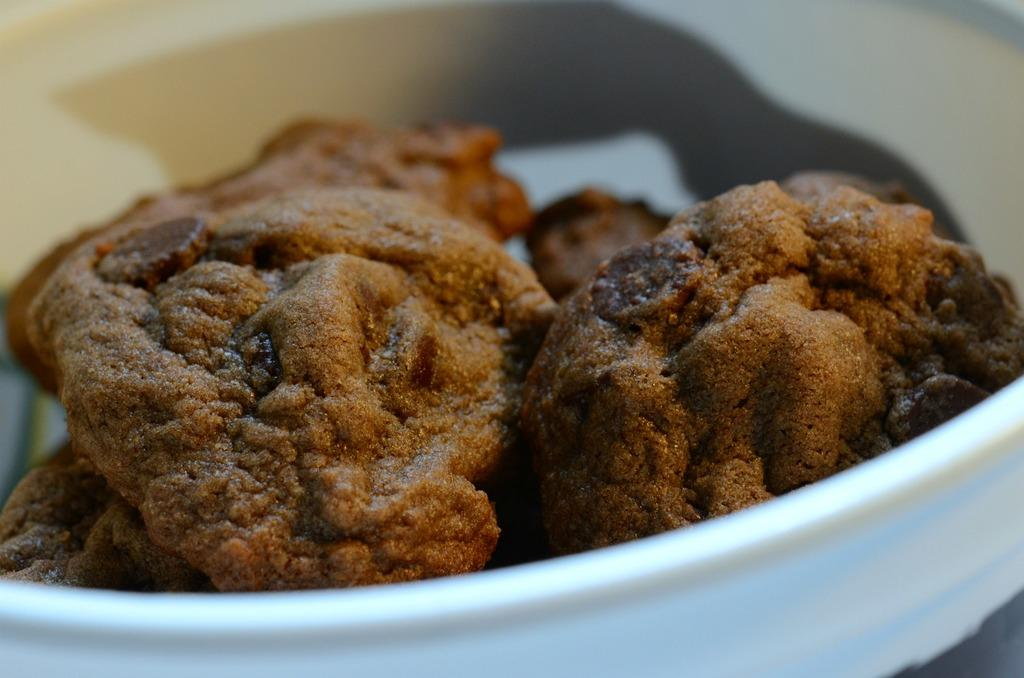What type of object is holding the food items in the image? The food items are in a white object in the image. How many pigs are visible on the silver board in the image? There are no pigs or silver board present in the image. 